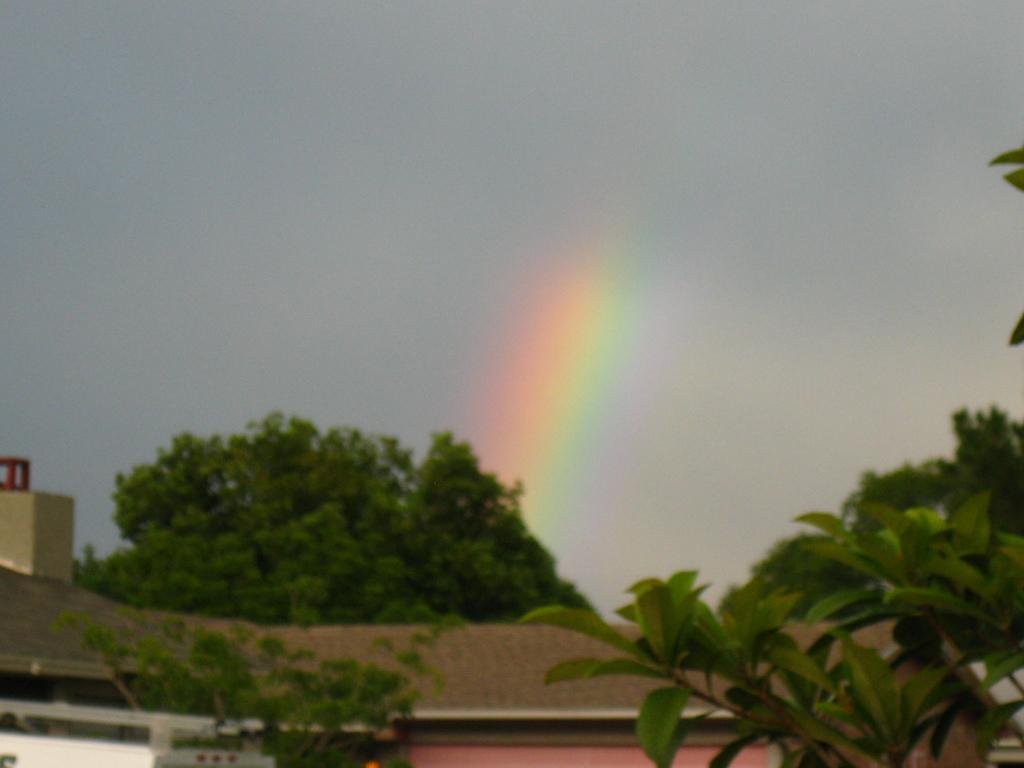Could you give a brief overview of what you see in this image? Here there are trees, this is house and a sky. 